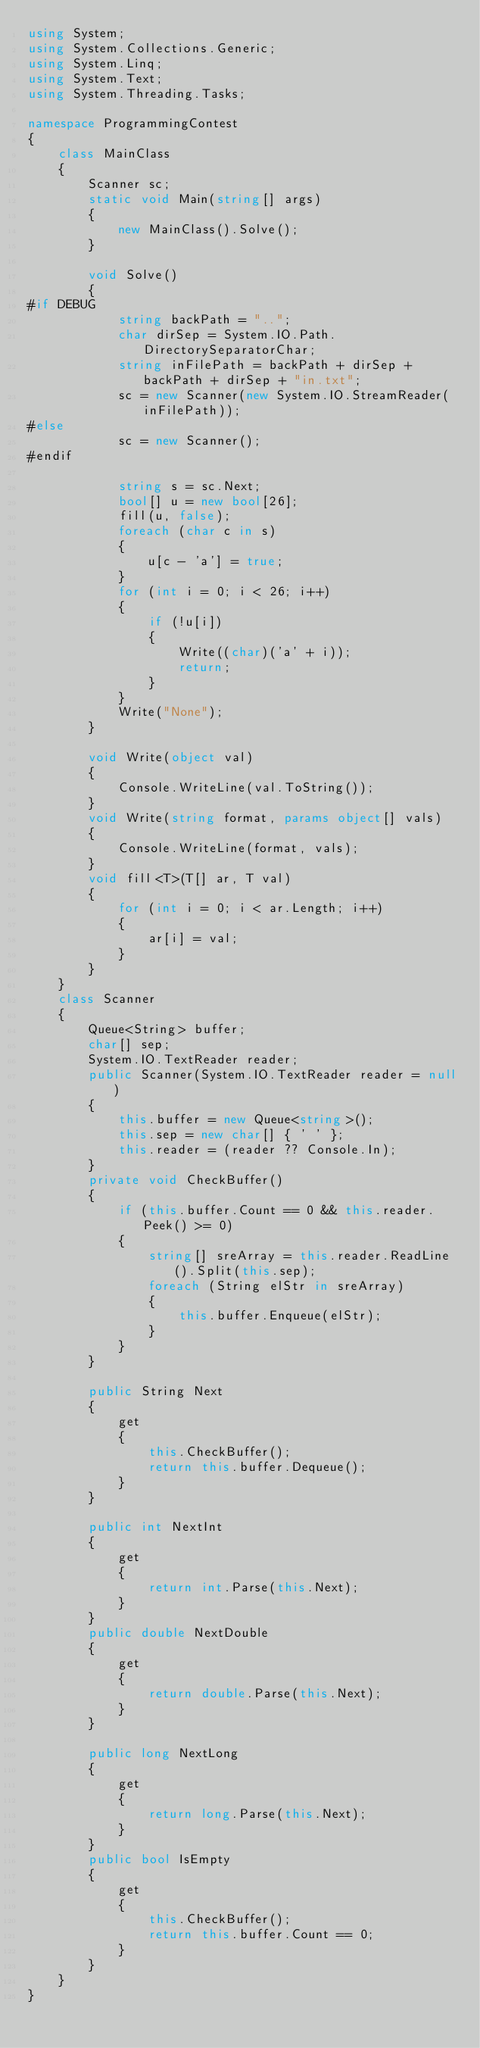Convert code to text. <code><loc_0><loc_0><loc_500><loc_500><_C#_>using System;
using System.Collections.Generic;
using System.Linq;
using System.Text;
using System.Threading.Tasks;

namespace ProgrammingContest
{
    class MainClass
    {
        Scanner sc;
        static void Main(string[] args)
        {
            new MainClass().Solve();
        }

        void Solve()
        {
#if DEBUG
            string backPath = "..";
            char dirSep = System.IO.Path.DirectorySeparatorChar;
            string inFilePath = backPath + dirSep + backPath + dirSep + "in.txt";
            sc = new Scanner(new System.IO.StreamReader(inFilePath));
#else
            sc = new Scanner();
#endif

            string s = sc.Next;
            bool[] u = new bool[26];
            fill(u, false);
            foreach (char c in s)
            {
                u[c - 'a'] = true;
            }
            for (int i = 0; i < 26; i++)
            {
                if (!u[i])
                {
                    Write((char)('a' + i));
                    return;
                }
            }
            Write("None");
        }

        void Write(object val)
        {
            Console.WriteLine(val.ToString());
        }
        void Write(string format, params object[] vals)
        {
            Console.WriteLine(format, vals);
        }
        void fill<T>(T[] ar, T val)
        {
            for (int i = 0; i < ar.Length; i++)
            {
                ar[i] = val;
            }
        }
    }
    class Scanner
    {
        Queue<String> buffer;
        char[] sep;
        System.IO.TextReader reader;
        public Scanner(System.IO.TextReader reader = null)
        {
            this.buffer = new Queue<string>();
            this.sep = new char[] { ' ' };
            this.reader = (reader ?? Console.In);
        }
        private void CheckBuffer()
        {
            if (this.buffer.Count == 0 && this.reader.Peek() >= 0)
            {
                string[] sreArray = this.reader.ReadLine().Split(this.sep);
                foreach (String elStr in sreArray)
                {
                    this.buffer.Enqueue(elStr);
                }
            }
        }

        public String Next
        {
            get
            {
                this.CheckBuffer();
                return this.buffer.Dequeue();
            }
        }

        public int NextInt
        {
            get
            {
                return int.Parse(this.Next);
            }
        }
        public double NextDouble
        {
            get
            {
                return double.Parse(this.Next);
            }
        }

        public long NextLong
        {
            get
            {
                return long.Parse(this.Next);
            }
        }
        public bool IsEmpty
        {
            get
            {
                this.CheckBuffer();
                return this.buffer.Count == 0;
            }
        }
    }
}
</code> 